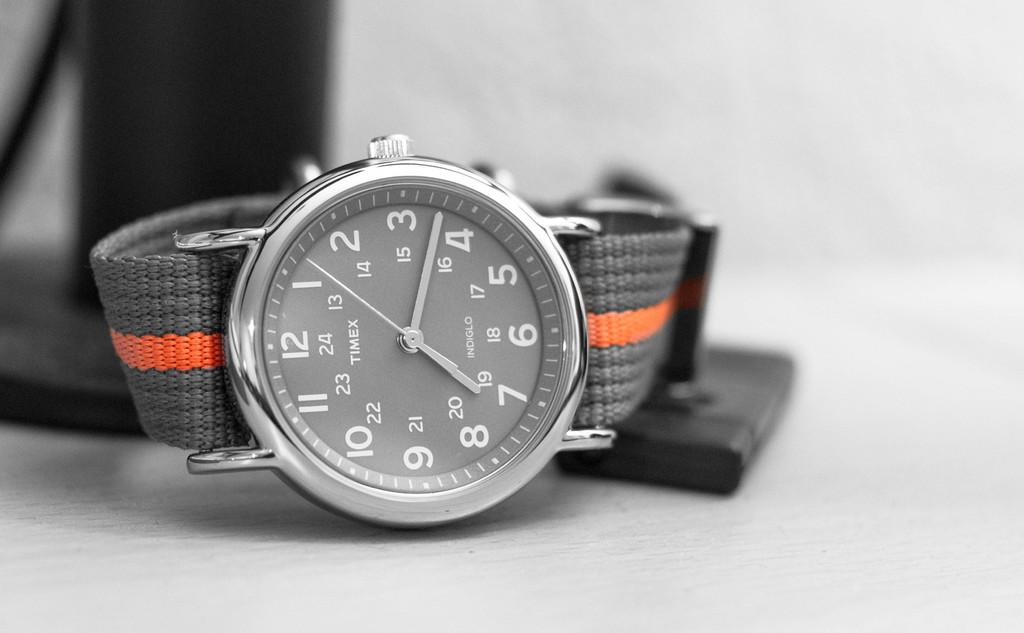<image>
Share a concise interpretation of the image provided. An analog Timex watch with a grey and orange band 